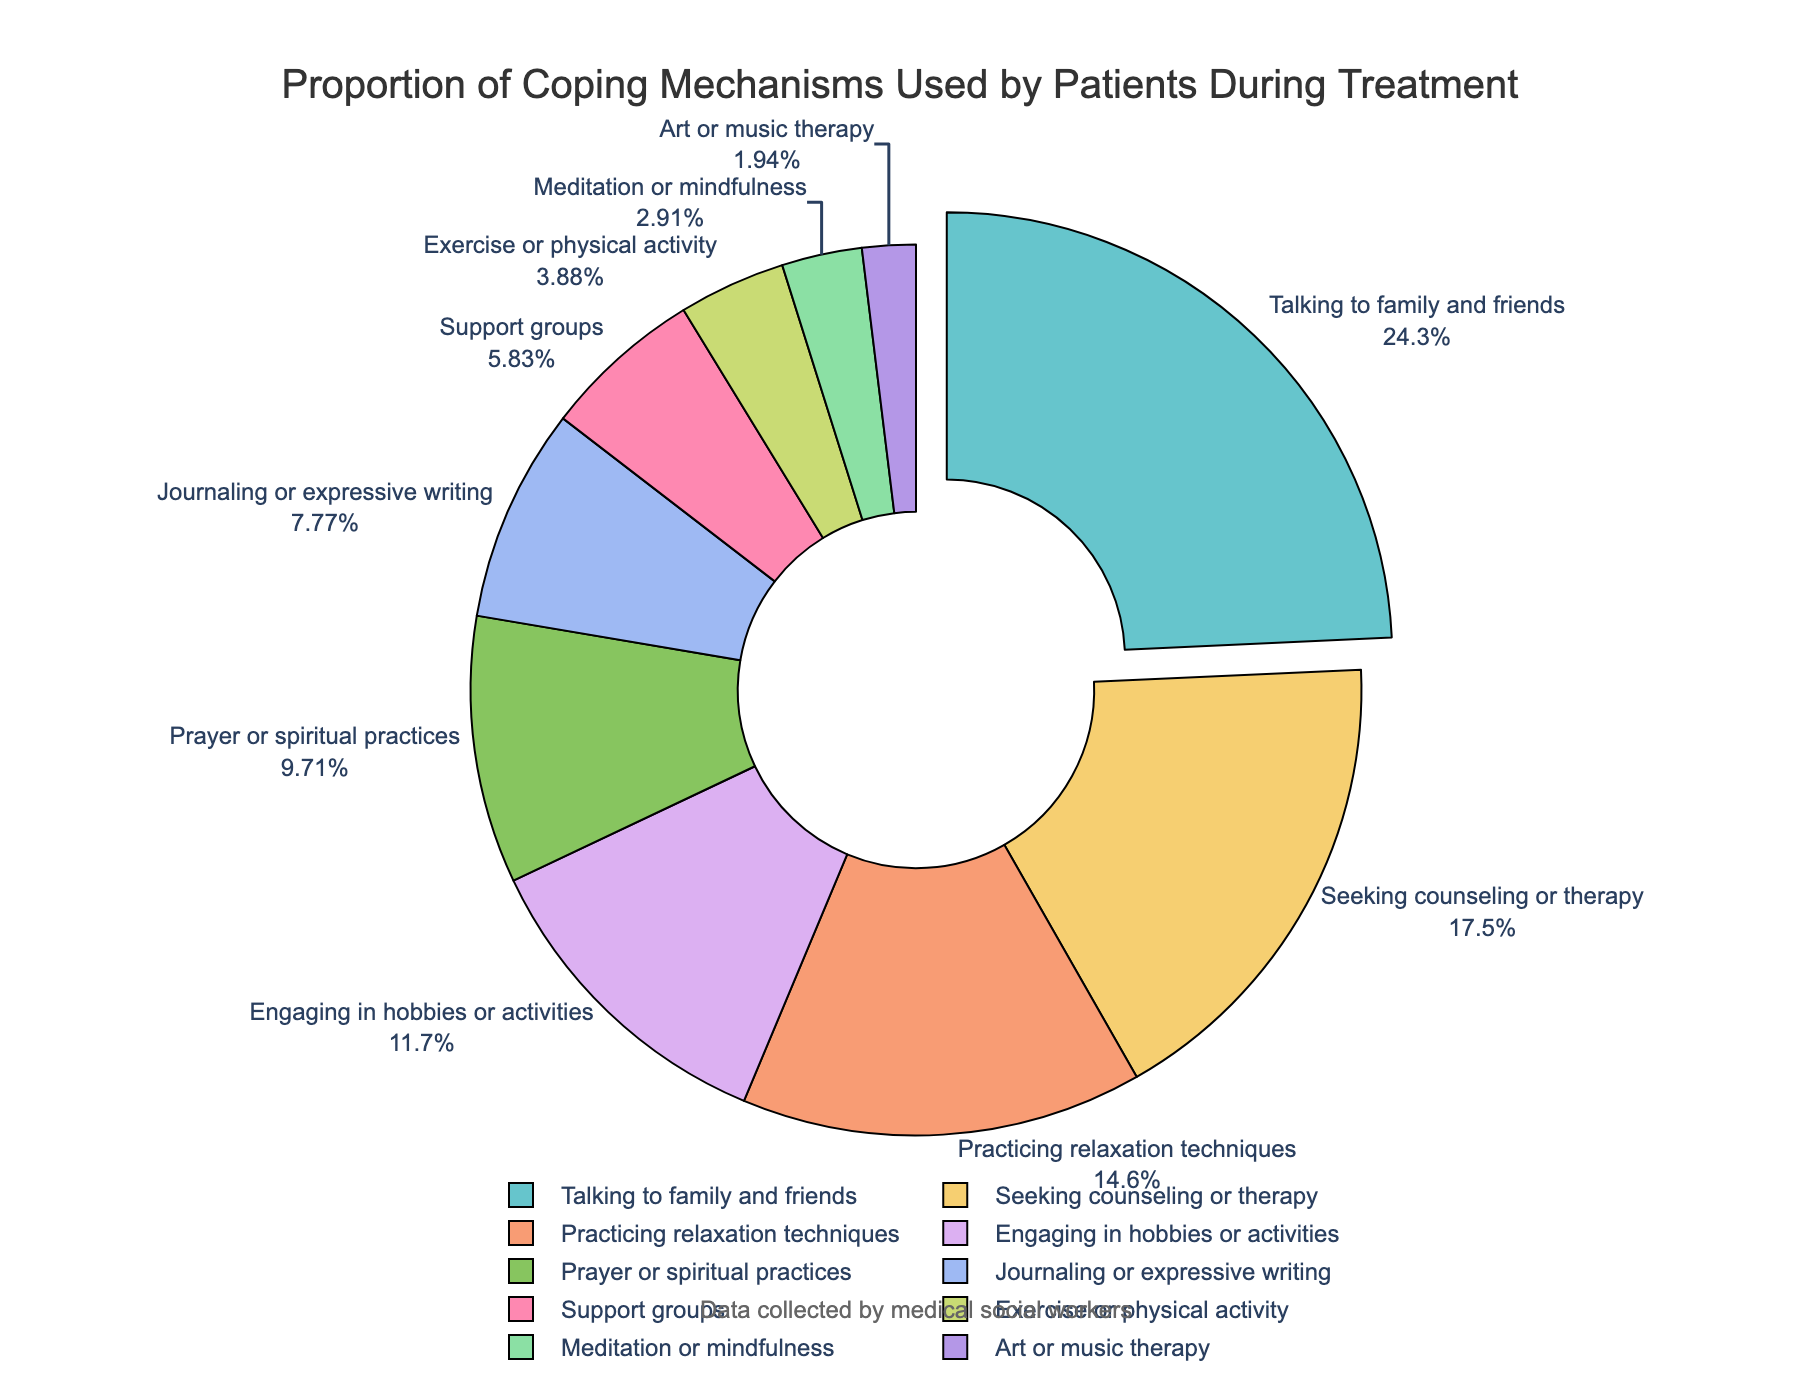Which coping mechanism is used by the highest proportion of patients? The slice with the largest pull-out indicates the coping mechanism with the highest proportion. It is labeled as "Talking to family and friends" with 25%.
Answer: Talking to family and friends Which coping mechanism is used by the least proportion of patients? The smallest slice on the pie chart represents the coping mechanism used by the least proportion of patients. It is labeled as "Art or music therapy" with 2%.
Answer: Art or music therapy How much more do patients use "Talking to family and friends" compared to "Exercise or physical activity"? The percentage for "Talking to family and friends" is 25%, and for "Exercise or physical activity" is 4%. The difference is calculated as 25% - 4% = 21%.
Answer: 21% Which three coping mechanisms collectively represent less than 10% of the total usage? By looking at the slices, we see "Art or music therapy" (2%), "Meditation or mindfulness" (3%), and "Exercise or physical activity" (4%) add up to a collective total of 9%.
Answer: Art or music therapy, Meditation or mindfulness, Exercise or physical activity Are there more patients using "Engaging in hobbies or activities" or "Seeking counseling or therapy"? The percentage for "Engaging in hobbies or activities" is 12%, and for "Seeking counseling or therapy" is 18%. Comparatively, more patients use "Seeking counseling or therapy".
Answer: Seeking counseling or therapy What is the total proportion of patients using either "Prayer or spiritual practices" or "Journaling or expressive writing"? The percentages are 10% for "Prayer or spiritual practices" and 8% for "Journaling or expressive writing". Adding these together gives 10% + 8% = 18%.
Answer: 18% What is the combined proportion of patients using any form of writing or self-reflection practices (Journaling or expressive writing and Prayer or spiritual practices)? "Journaling or expressive writing" has 8% and "Prayer or spiritual practices" has 10%. Their combined proportion is 8% + 10% = 18%.
Answer: 18% Which coping mechanism represents exactly one-eighth of the total usage? One-eighth of 100% is 12.5%. None of the percentages in the chart is exactly 12.5%; however, "Engaging in hobbies or activities" is close with 12%.
Answer: None 